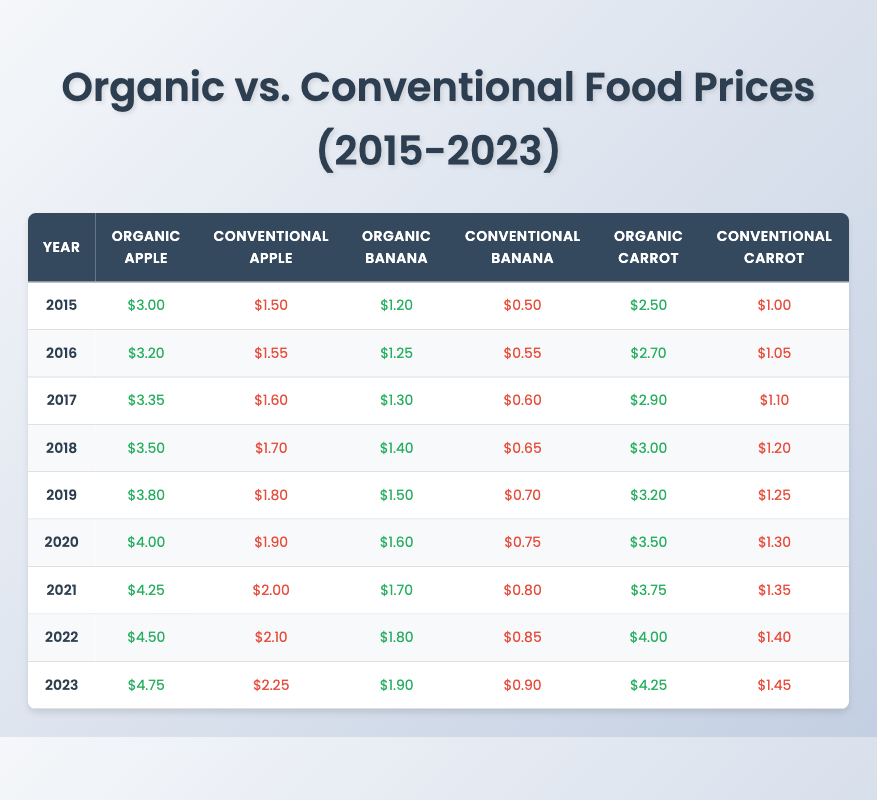What was the price of organic bananas in 2020? In the table, under the 2020 row and the organic banana column, the price is listed as $1.60.
Answer: $1.60 What is the price difference between organic and conventional carrots in 2022? In 2022, the price for organic carrots is $4.00 and for conventional carrots, it is $1.40. The difference is calculated as $4.00 - $1.40 = $2.60.
Answer: $2.60 Was the price of conventional apples higher than organic apples in any year? By comparing the two columns for each year, it is clear that organic apples are always more expensive than conventional apples in the entire period from 2015 to 2023.
Answer: No What is the trend of organic apple prices from 2015 to 2023? The organic apple prices increased from $3.00 in 2015 to $4.75 in 2023. This increase can be calculated year by year to confirm a consistent upward trend.
Answer: Increasing In which year did organic banana prices first exceed $1.50? By examining the organic banana prices year by year, it shows that the price crossed $1.50 in 2019, as it was $1.50 in that year but did not exceed it in previous years.
Answer: 2019 What was the highest recorded price for conventional bananas over the years? Looking at the column for conventional banana prices, the highest value is in 2023, where it is listed as $0.90.
Answer: $0.90 What is the average price of organic carrots from 2015 to 2023? The organic carrot prices from 2015 to 2023 are $2.50, $2.70, $2.90, $3.00, $3.20, $3.50, $3.75, $4.00, and $4.25. Adding them gives a total of $27.10, and dividing by 9 years yields an average of $3.01.
Answer: $3.01 How much did the price of organic bananas increase from 2015 to 2023? The organic banana price in 2015 was $1.20 and in 2023 it is $1.90. The increase is calculated as $1.90 - $1.20 = $0.70.
Answer: $0.70 What percentage increase did conventional apple prices see from 2015 to 2023? The price in 2015 was $1.50 and in 2023 it is $2.25. To calculate the percentage increase: (($2.25 - $1.50) / $1.50) * 100 = 50%.
Answer: 50% Which category of produce consistently had the highest price throughout the years? By comparing all prices across the years, it is evident that organic apples always had the highest price, starting from $3.00 in 2015 and reaching $4.75 in 2023.
Answer: Organic apples 